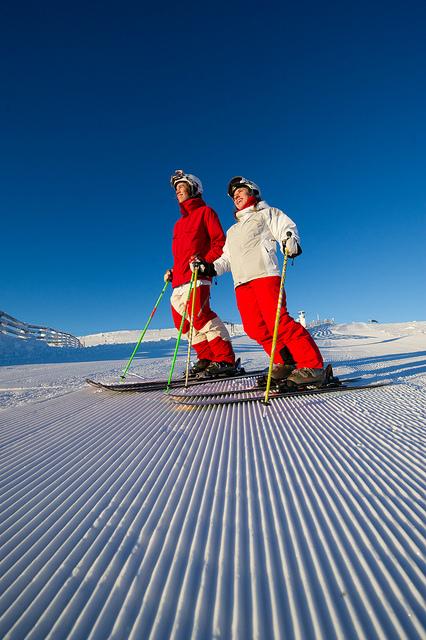How many people are shown?
Quick response, please. 2. What sport is represented in this photo?
Keep it brief. Skiing. What is in the men's head?
Concise answer only. Helmet. Are the men having fun?
Keep it brief. Yes. How many people are there?
Concise answer only. 2. 